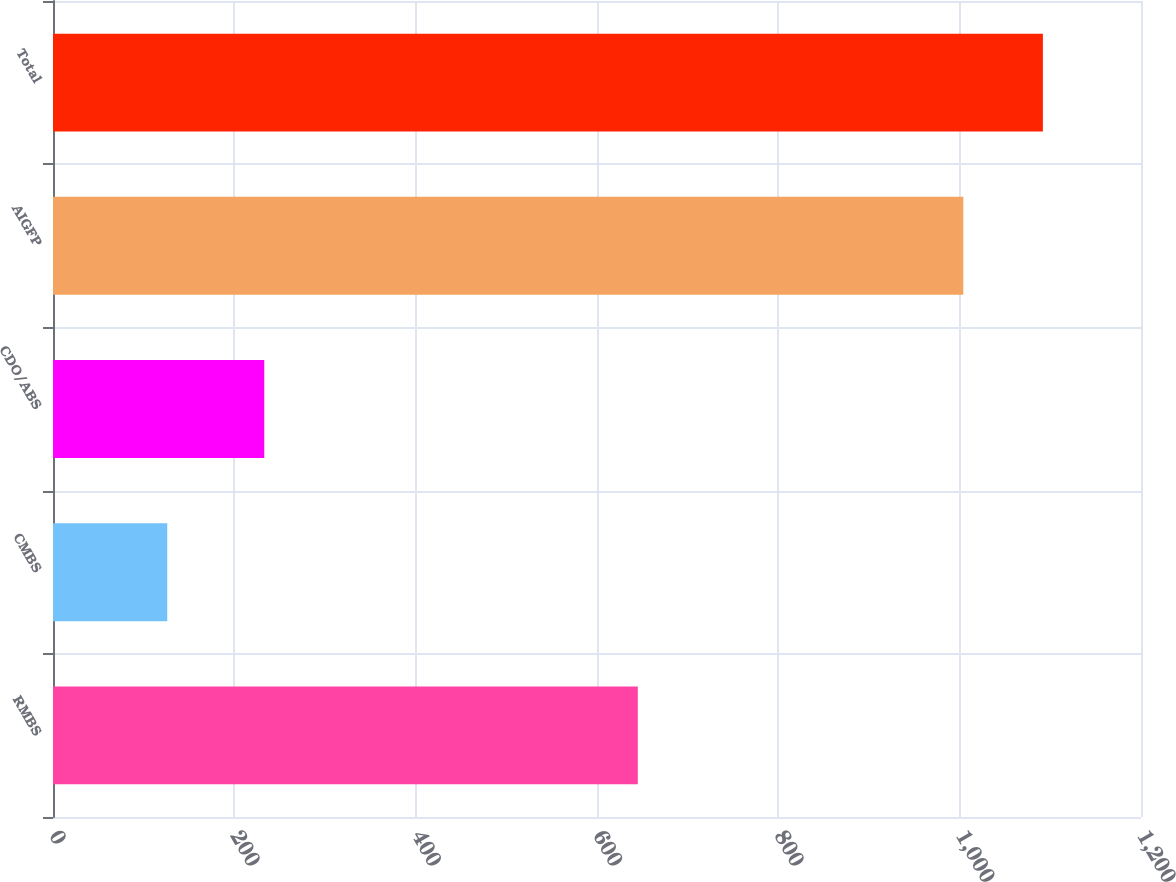<chart> <loc_0><loc_0><loc_500><loc_500><bar_chart><fcel>RMBS<fcel>CMBS<fcel>CDO/ABS<fcel>AIGFP<fcel>Total<nl><fcel>645<fcel>126<fcel>233<fcel>1004<fcel>1091.8<nl></chart> 